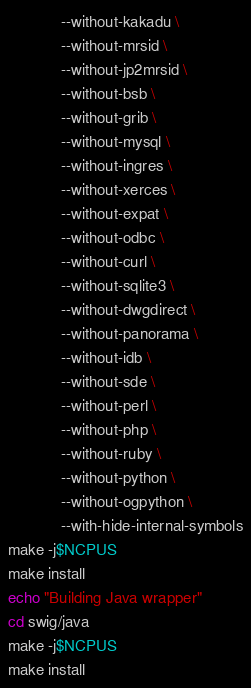Convert code to text. <code><loc_0><loc_0><loc_500><loc_500><_Bash_>            --without-kakadu \
            --without-mrsid \
            --without-jp2mrsid \
            --without-bsb \
            --without-grib \
            --without-mysql \
            --without-ingres \
            --without-xerces \
            --without-expat \
            --without-odbc \
            --without-curl \
            --without-sqlite3 \
            --without-dwgdirect \
            --without-panorama \
            --without-idb \
            --without-sde \
            --without-perl \
            --without-php \
            --without-ruby \
            --without-python \
            --without-ogpython \
            --with-hide-internal-symbols
make -j$NCPUS
make install
echo "Building Java wrapper"
cd swig/java
make -j$NCPUS
make install
</code> 